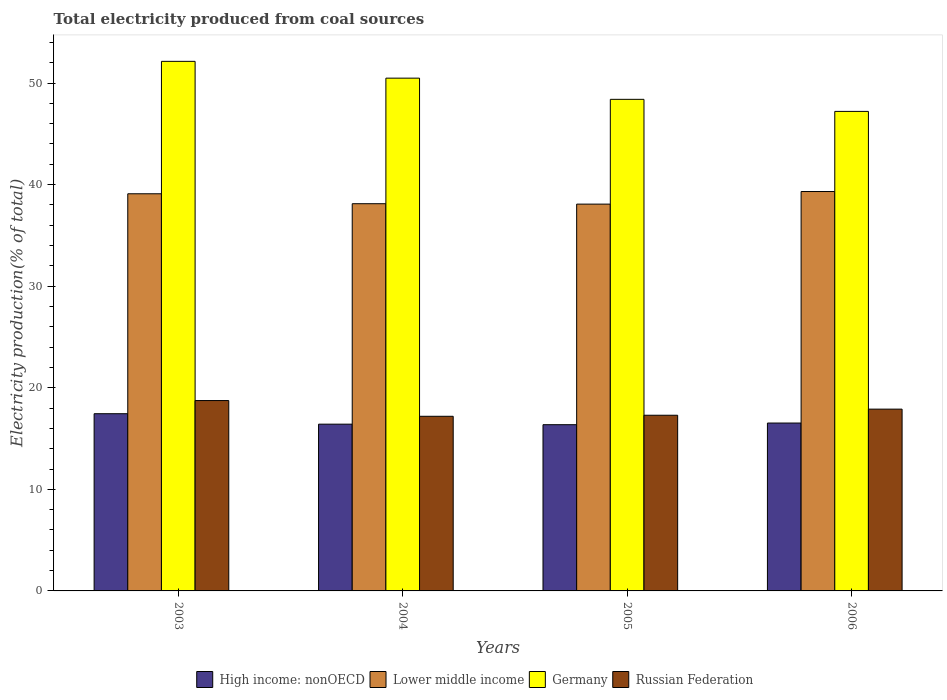How many different coloured bars are there?
Your answer should be very brief. 4. How many groups of bars are there?
Your answer should be very brief. 4. How many bars are there on the 4th tick from the left?
Make the answer very short. 4. How many bars are there on the 2nd tick from the right?
Ensure brevity in your answer.  4. In how many cases, is the number of bars for a given year not equal to the number of legend labels?
Offer a terse response. 0. What is the total electricity produced in Russian Federation in 2005?
Provide a succinct answer. 17.3. Across all years, what is the maximum total electricity produced in Lower middle income?
Offer a very short reply. 39.32. Across all years, what is the minimum total electricity produced in Lower middle income?
Your answer should be compact. 38.08. In which year was the total electricity produced in Lower middle income maximum?
Keep it short and to the point. 2006. In which year was the total electricity produced in Lower middle income minimum?
Offer a very short reply. 2005. What is the total total electricity produced in Russian Federation in the graph?
Give a very brief answer. 71.13. What is the difference between the total electricity produced in High income: nonOECD in 2005 and that in 2006?
Make the answer very short. -0.16. What is the difference between the total electricity produced in Russian Federation in 2006 and the total electricity produced in Lower middle income in 2004?
Provide a succinct answer. -20.22. What is the average total electricity produced in Germany per year?
Your answer should be very brief. 49.56. In the year 2003, what is the difference between the total electricity produced in High income: nonOECD and total electricity produced in Germany?
Provide a short and direct response. -34.69. What is the ratio of the total electricity produced in High income: nonOECD in 2004 to that in 2006?
Provide a short and direct response. 0.99. Is the total electricity produced in High income: nonOECD in 2003 less than that in 2005?
Make the answer very short. No. What is the difference between the highest and the second highest total electricity produced in Russian Federation?
Your answer should be very brief. 0.84. What is the difference between the highest and the lowest total electricity produced in High income: nonOECD?
Keep it short and to the point. 1.08. Is the sum of the total electricity produced in Germany in 2003 and 2005 greater than the maximum total electricity produced in Russian Federation across all years?
Provide a short and direct response. Yes. What does the 2nd bar from the left in 2005 represents?
Offer a terse response. Lower middle income. What does the 3rd bar from the right in 2004 represents?
Your answer should be very brief. Lower middle income. How many years are there in the graph?
Ensure brevity in your answer.  4. What is the difference between two consecutive major ticks on the Y-axis?
Your response must be concise. 10. How are the legend labels stacked?
Make the answer very short. Horizontal. What is the title of the graph?
Keep it short and to the point. Total electricity produced from coal sources. Does "Slovenia" appear as one of the legend labels in the graph?
Your answer should be very brief. No. What is the Electricity production(% of total) of High income: nonOECD in 2003?
Keep it short and to the point. 17.45. What is the Electricity production(% of total) of Lower middle income in 2003?
Ensure brevity in your answer.  39.1. What is the Electricity production(% of total) of Germany in 2003?
Offer a terse response. 52.14. What is the Electricity production(% of total) of Russian Federation in 2003?
Keep it short and to the point. 18.74. What is the Electricity production(% of total) in High income: nonOECD in 2004?
Ensure brevity in your answer.  16.42. What is the Electricity production(% of total) in Lower middle income in 2004?
Provide a succinct answer. 38.12. What is the Electricity production(% of total) in Germany in 2004?
Your answer should be compact. 50.48. What is the Electricity production(% of total) of Russian Federation in 2004?
Ensure brevity in your answer.  17.19. What is the Electricity production(% of total) in High income: nonOECD in 2005?
Your response must be concise. 16.37. What is the Electricity production(% of total) in Lower middle income in 2005?
Provide a short and direct response. 38.08. What is the Electricity production(% of total) of Germany in 2005?
Ensure brevity in your answer.  48.4. What is the Electricity production(% of total) in Russian Federation in 2005?
Offer a very short reply. 17.3. What is the Electricity production(% of total) in High income: nonOECD in 2006?
Keep it short and to the point. 16.53. What is the Electricity production(% of total) of Lower middle income in 2006?
Keep it short and to the point. 39.32. What is the Electricity production(% of total) in Germany in 2006?
Your answer should be compact. 47.21. What is the Electricity production(% of total) of Russian Federation in 2006?
Offer a very short reply. 17.9. Across all years, what is the maximum Electricity production(% of total) in High income: nonOECD?
Keep it short and to the point. 17.45. Across all years, what is the maximum Electricity production(% of total) in Lower middle income?
Your response must be concise. 39.32. Across all years, what is the maximum Electricity production(% of total) in Germany?
Provide a short and direct response. 52.14. Across all years, what is the maximum Electricity production(% of total) of Russian Federation?
Keep it short and to the point. 18.74. Across all years, what is the minimum Electricity production(% of total) in High income: nonOECD?
Give a very brief answer. 16.37. Across all years, what is the minimum Electricity production(% of total) in Lower middle income?
Give a very brief answer. 38.08. Across all years, what is the minimum Electricity production(% of total) of Germany?
Provide a succinct answer. 47.21. Across all years, what is the minimum Electricity production(% of total) in Russian Federation?
Make the answer very short. 17.19. What is the total Electricity production(% of total) in High income: nonOECD in the graph?
Your response must be concise. 66.76. What is the total Electricity production(% of total) in Lower middle income in the graph?
Offer a very short reply. 154.62. What is the total Electricity production(% of total) of Germany in the graph?
Your answer should be compact. 198.23. What is the total Electricity production(% of total) in Russian Federation in the graph?
Offer a very short reply. 71.13. What is the difference between the Electricity production(% of total) in High income: nonOECD in 2003 and that in 2004?
Provide a short and direct response. 1.03. What is the difference between the Electricity production(% of total) in Lower middle income in 2003 and that in 2004?
Keep it short and to the point. 0.98. What is the difference between the Electricity production(% of total) of Germany in 2003 and that in 2004?
Your answer should be compact. 1.65. What is the difference between the Electricity production(% of total) in Russian Federation in 2003 and that in 2004?
Your response must be concise. 1.55. What is the difference between the Electricity production(% of total) of High income: nonOECD in 2003 and that in 2005?
Offer a very short reply. 1.08. What is the difference between the Electricity production(% of total) of Lower middle income in 2003 and that in 2005?
Offer a very short reply. 1.02. What is the difference between the Electricity production(% of total) in Germany in 2003 and that in 2005?
Your response must be concise. 3.74. What is the difference between the Electricity production(% of total) of Russian Federation in 2003 and that in 2005?
Keep it short and to the point. 1.45. What is the difference between the Electricity production(% of total) of High income: nonOECD in 2003 and that in 2006?
Make the answer very short. 0.92. What is the difference between the Electricity production(% of total) of Lower middle income in 2003 and that in 2006?
Your answer should be compact. -0.22. What is the difference between the Electricity production(% of total) in Germany in 2003 and that in 2006?
Make the answer very short. 4.93. What is the difference between the Electricity production(% of total) of Russian Federation in 2003 and that in 2006?
Offer a terse response. 0.84. What is the difference between the Electricity production(% of total) in High income: nonOECD in 2004 and that in 2005?
Make the answer very short. 0.05. What is the difference between the Electricity production(% of total) of Lower middle income in 2004 and that in 2005?
Provide a short and direct response. 0.04. What is the difference between the Electricity production(% of total) in Germany in 2004 and that in 2005?
Offer a terse response. 2.09. What is the difference between the Electricity production(% of total) of Russian Federation in 2004 and that in 2005?
Give a very brief answer. -0.1. What is the difference between the Electricity production(% of total) in High income: nonOECD in 2004 and that in 2006?
Provide a succinct answer. -0.11. What is the difference between the Electricity production(% of total) in Lower middle income in 2004 and that in 2006?
Keep it short and to the point. -1.2. What is the difference between the Electricity production(% of total) in Germany in 2004 and that in 2006?
Ensure brevity in your answer.  3.27. What is the difference between the Electricity production(% of total) of Russian Federation in 2004 and that in 2006?
Offer a terse response. -0.71. What is the difference between the Electricity production(% of total) of High income: nonOECD in 2005 and that in 2006?
Provide a succinct answer. -0.16. What is the difference between the Electricity production(% of total) of Lower middle income in 2005 and that in 2006?
Offer a very short reply. -1.24. What is the difference between the Electricity production(% of total) of Germany in 2005 and that in 2006?
Your answer should be very brief. 1.19. What is the difference between the Electricity production(% of total) of Russian Federation in 2005 and that in 2006?
Your answer should be very brief. -0.6. What is the difference between the Electricity production(% of total) in High income: nonOECD in 2003 and the Electricity production(% of total) in Lower middle income in 2004?
Keep it short and to the point. -20.67. What is the difference between the Electricity production(% of total) in High income: nonOECD in 2003 and the Electricity production(% of total) in Germany in 2004?
Offer a very short reply. -33.04. What is the difference between the Electricity production(% of total) in High income: nonOECD in 2003 and the Electricity production(% of total) in Russian Federation in 2004?
Your answer should be very brief. 0.25. What is the difference between the Electricity production(% of total) in Lower middle income in 2003 and the Electricity production(% of total) in Germany in 2004?
Provide a short and direct response. -11.38. What is the difference between the Electricity production(% of total) in Lower middle income in 2003 and the Electricity production(% of total) in Russian Federation in 2004?
Give a very brief answer. 21.91. What is the difference between the Electricity production(% of total) of Germany in 2003 and the Electricity production(% of total) of Russian Federation in 2004?
Ensure brevity in your answer.  34.94. What is the difference between the Electricity production(% of total) of High income: nonOECD in 2003 and the Electricity production(% of total) of Lower middle income in 2005?
Your answer should be compact. -20.64. What is the difference between the Electricity production(% of total) of High income: nonOECD in 2003 and the Electricity production(% of total) of Germany in 2005?
Give a very brief answer. -30.95. What is the difference between the Electricity production(% of total) in High income: nonOECD in 2003 and the Electricity production(% of total) in Russian Federation in 2005?
Keep it short and to the point. 0.15. What is the difference between the Electricity production(% of total) in Lower middle income in 2003 and the Electricity production(% of total) in Germany in 2005?
Offer a very short reply. -9.3. What is the difference between the Electricity production(% of total) in Lower middle income in 2003 and the Electricity production(% of total) in Russian Federation in 2005?
Your response must be concise. 21.8. What is the difference between the Electricity production(% of total) of Germany in 2003 and the Electricity production(% of total) of Russian Federation in 2005?
Ensure brevity in your answer.  34.84. What is the difference between the Electricity production(% of total) of High income: nonOECD in 2003 and the Electricity production(% of total) of Lower middle income in 2006?
Provide a succinct answer. -21.87. What is the difference between the Electricity production(% of total) of High income: nonOECD in 2003 and the Electricity production(% of total) of Germany in 2006?
Your answer should be very brief. -29.76. What is the difference between the Electricity production(% of total) in High income: nonOECD in 2003 and the Electricity production(% of total) in Russian Federation in 2006?
Give a very brief answer. -0.45. What is the difference between the Electricity production(% of total) in Lower middle income in 2003 and the Electricity production(% of total) in Germany in 2006?
Your response must be concise. -8.11. What is the difference between the Electricity production(% of total) in Lower middle income in 2003 and the Electricity production(% of total) in Russian Federation in 2006?
Offer a very short reply. 21.2. What is the difference between the Electricity production(% of total) in Germany in 2003 and the Electricity production(% of total) in Russian Federation in 2006?
Offer a terse response. 34.24. What is the difference between the Electricity production(% of total) in High income: nonOECD in 2004 and the Electricity production(% of total) in Lower middle income in 2005?
Make the answer very short. -21.66. What is the difference between the Electricity production(% of total) in High income: nonOECD in 2004 and the Electricity production(% of total) in Germany in 2005?
Offer a terse response. -31.98. What is the difference between the Electricity production(% of total) in High income: nonOECD in 2004 and the Electricity production(% of total) in Russian Federation in 2005?
Offer a terse response. -0.88. What is the difference between the Electricity production(% of total) of Lower middle income in 2004 and the Electricity production(% of total) of Germany in 2005?
Give a very brief answer. -10.28. What is the difference between the Electricity production(% of total) in Lower middle income in 2004 and the Electricity production(% of total) in Russian Federation in 2005?
Provide a succinct answer. 20.82. What is the difference between the Electricity production(% of total) of Germany in 2004 and the Electricity production(% of total) of Russian Federation in 2005?
Your answer should be compact. 33.19. What is the difference between the Electricity production(% of total) of High income: nonOECD in 2004 and the Electricity production(% of total) of Lower middle income in 2006?
Ensure brevity in your answer.  -22.9. What is the difference between the Electricity production(% of total) of High income: nonOECD in 2004 and the Electricity production(% of total) of Germany in 2006?
Offer a terse response. -30.79. What is the difference between the Electricity production(% of total) in High income: nonOECD in 2004 and the Electricity production(% of total) in Russian Federation in 2006?
Your answer should be compact. -1.48. What is the difference between the Electricity production(% of total) in Lower middle income in 2004 and the Electricity production(% of total) in Germany in 2006?
Provide a short and direct response. -9.09. What is the difference between the Electricity production(% of total) of Lower middle income in 2004 and the Electricity production(% of total) of Russian Federation in 2006?
Offer a terse response. 20.22. What is the difference between the Electricity production(% of total) of Germany in 2004 and the Electricity production(% of total) of Russian Federation in 2006?
Your answer should be compact. 32.59. What is the difference between the Electricity production(% of total) of High income: nonOECD in 2005 and the Electricity production(% of total) of Lower middle income in 2006?
Your answer should be very brief. -22.96. What is the difference between the Electricity production(% of total) of High income: nonOECD in 2005 and the Electricity production(% of total) of Germany in 2006?
Your response must be concise. -30.84. What is the difference between the Electricity production(% of total) of High income: nonOECD in 2005 and the Electricity production(% of total) of Russian Federation in 2006?
Provide a short and direct response. -1.53. What is the difference between the Electricity production(% of total) in Lower middle income in 2005 and the Electricity production(% of total) in Germany in 2006?
Offer a very short reply. -9.13. What is the difference between the Electricity production(% of total) in Lower middle income in 2005 and the Electricity production(% of total) in Russian Federation in 2006?
Make the answer very short. 20.18. What is the difference between the Electricity production(% of total) in Germany in 2005 and the Electricity production(% of total) in Russian Federation in 2006?
Offer a very short reply. 30.5. What is the average Electricity production(% of total) of High income: nonOECD per year?
Your answer should be very brief. 16.69. What is the average Electricity production(% of total) of Lower middle income per year?
Your response must be concise. 38.66. What is the average Electricity production(% of total) in Germany per year?
Provide a succinct answer. 49.56. What is the average Electricity production(% of total) in Russian Federation per year?
Offer a very short reply. 17.78. In the year 2003, what is the difference between the Electricity production(% of total) in High income: nonOECD and Electricity production(% of total) in Lower middle income?
Make the answer very short. -21.65. In the year 2003, what is the difference between the Electricity production(% of total) of High income: nonOECD and Electricity production(% of total) of Germany?
Provide a succinct answer. -34.69. In the year 2003, what is the difference between the Electricity production(% of total) in High income: nonOECD and Electricity production(% of total) in Russian Federation?
Your answer should be compact. -1.29. In the year 2003, what is the difference between the Electricity production(% of total) of Lower middle income and Electricity production(% of total) of Germany?
Provide a succinct answer. -13.04. In the year 2003, what is the difference between the Electricity production(% of total) of Lower middle income and Electricity production(% of total) of Russian Federation?
Provide a succinct answer. 20.36. In the year 2003, what is the difference between the Electricity production(% of total) of Germany and Electricity production(% of total) of Russian Federation?
Offer a very short reply. 33.39. In the year 2004, what is the difference between the Electricity production(% of total) in High income: nonOECD and Electricity production(% of total) in Lower middle income?
Provide a succinct answer. -21.7. In the year 2004, what is the difference between the Electricity production(% of total) of High income: nonOECD and Electricity production(% of total) of Germany?
Provide a short and direct response. -34.07. In the year 2004, what is the difference between the Electricity production(% of total) in High income: nonOECD and Electricity production(% of total) in Russian Federation?
Your answer should be compact. -0.78. In the year 2004, what is the difference between the Electricity production(% of total) of Lower middle income and Electricity production(% of total) of Germany?
Offer a very short reply. -12.36. In the year 2004, what is the difference between the Electricity production(% of total) in Lower middle income and Electricity production(% of total) in Russian Federation?
Your response must be concise. 20.93. In the year 2004, what is the difference between the Electricity production(% of total) of Germany and Electricity production(% of total) of Russian Federation?
Provide a short and direct response. 33.29. In the year 2005, what is the difference between the Electricity production(% of total) of High income: nonOECD and Electricity production(% of total) of Lower middle income?
Make the answer very short. -21.72. In the year 2005, what is the difference between the Electricity production(% of total) of High income: nonOECD and Electricity production(% of total) of Germany?
Give a very brief answer. -32.03. In the year 2005, what is the difference between the Electricity production(% of total) in High income: nonOECD and Electricity production(% of total) in Russian Federation?
Give a very brief answer. -0.93. In the year 2005, what is the difference between the Electricity production(% of total) of Lower middle income and Electricity production(% of total) of Germany?
Your answer should be compact. -10.32. In the year 2005, what is the difference between the Electricity production(% of total) in Lower middle income and Electricity production(% of total) in Russian Federation?
Your answer should be very brief. 20.79. In the year 2005, what is the difference between the Electricity production(% of total) in Germany and Electricity production(% of total) in Russian Federation?
Your answer should be compact. 31.1. In the year 2006, what is the difference between the Electricity production(% of total) of High income: nonOECD and Electricity production(% of total) of Lower middle income?
Ensure brevity in your answer.  -22.79. In the year 2006, what is the difference between the Electricity production(% of total) of High income: nonOECD and Electricity production(% of total) of Germany?
Offer a very short reply. -30.68. In the year 2006, what is the difference between the Electricity production(% of total) in High income: nonOECD and Electricity production(% of total) in Russian Federation?
Offer a very short reply. -1.37. In the year 2006, what is the difference between the Electricity production(% of total) of Lower middle income and Electricity production(% of total) of Germany?
Make the answer very short. -7.89. In the year 2006, what is the difference between the Electricity production(% of total) of Lower middle income and Electricity production(% of total) of Russian Federation?
Provide a succinct answer. 21.42. In the year 2006, what is the difference between the Electricity production(% of total) of Germany and Electricity production(% of total) of Russian Federation?
Offer a terse response. 29.31. What is the ratio of the Electricity production(% of total) of High income: nonOECD in 2003 to that in 2004?
Your answer should be compact. 1.06. What is the ratio of the Electricity production(% of total) in Lower middle income in 2003 to that in 2004?
Provide a succinct answer. 1.03. What is the ratio of the Electricity production(% of total) in Germany in 2003 to that in 2004?
Your answer should be compact. 1.03. What is the ratio of the Electricity production(% of total) in Russian Federation in 2003 to that in 2004?
Your answer should be very brief. 1.09. What is the ratio of the Electricity production(% of total) in High income: nonOECD in 2003 to that in 2005?
Provide a short and direct response. 1.07. What is the ratio of the Electricity production(% of total) of Lower middle income in 2003 to that in 2005?
Your answer should be very brief. 1.03. What is the ratio of the Electricity production(% of total) in Germany in 2003 to that in 2005?
Make the answer very short. 1.08. What is the ratio of the Electricity production(% of total) in Russian Federation in 2003 to that in 2005?
Your answer should be compact. 1.08. What is the ratio of the Electricity production(% of total) in High income: nonOECD in 2003 to that in 2006?
Your answer should be very brief. 1.06. What is the ratio of the Electricity production(% of total) of Germany in 2003 to that in 2006?
Give a very brief answer. 1.1. What is the ratio of the Electricity production(% of total) of Russian Federation in 2003 to that in 2006?
Your answer should be compact. 1.05. What is the ratio of the Electricity production(% of total) in High income: nonOECD in 2004 to that in 2005?
Your response must be concise. 1. What is the ratio of the Electricity production(% of total) in Germany in 2004 to that in 2005?
Give a very brief answer. 1.04. What is the ratio of the Electricity production(% of total) in Russian Federation in 2004 to that in 2005?
Make the answer very short. 0.99. What is the ratio of the Electricity production(% of total) in High income: nonOECD in 2004 to that in 2006?
Ensure brevity in your answer.  0.99. What is the ratio of the Electricity production(% of total) in Lower middle income in 2004 to that in 2006?
Ensure brevity in your answer.  0.97. What is the ratio of the Electricity production(% of total) in Germany in 2004 to that in 2006?
Keep it short and to the point. 1.07. What is the ratio of the Electricity production(% of total) of Russian Federation in 2004 to that in 2006?
Offer a terse response. 0.96. What is the ratio of the Electricity production(% of total) of High income: nonOECD in 2005 to that in 2006?
Offer a terse response. 0.99. What is the ratio of the Electricity production(% of total) in Lower middle income in 2005 to that in 2006?
Provide a succinct answer. 0.97. What is the ratio of the Electricity production(% of total) of Germany in 2005 to that in 2006?
Provide a short and direct response. 1.03. What is the ratio of the Electricity production(% of total) in Russian Federation in 2005 to that in 2006?
Your response must be concise. 0.97. What is the difference between the highest and the second highest Electricity production(% of total) in High income: nonOECD?
Provide a succinct answer. 0.92. What is the difference between the highest and the second highest Electricity production(% of total) in Lower middle income?
Your answer should be very brief. 0.22. What is the difference between the highest and the second highest Electricity production(% of total) in Germany?
Keep it short and to the point. 1.65. What is the difference between the highest and the second highest Electricity production(% of total) of Russian Federation?
Provide a short and direct response. 0.84. What is the difference between the highest and the lowest Electricity production(% of total) of High income: nonOECD?
Your answer should be very brief. 1.08. What is the difference between the highest and the lowest Electricity production(% of total) of Lower middle income?
Your answer should be compact. 1.24. What is the difference between the highest and the lowest Electricity production(% of total) of Germany?
Offer a terse response. 4.93. What is the difference between the highest and the lowest Electricity production(% of total) in Russian Federation?
Provide a succinct answer. 1.55. 